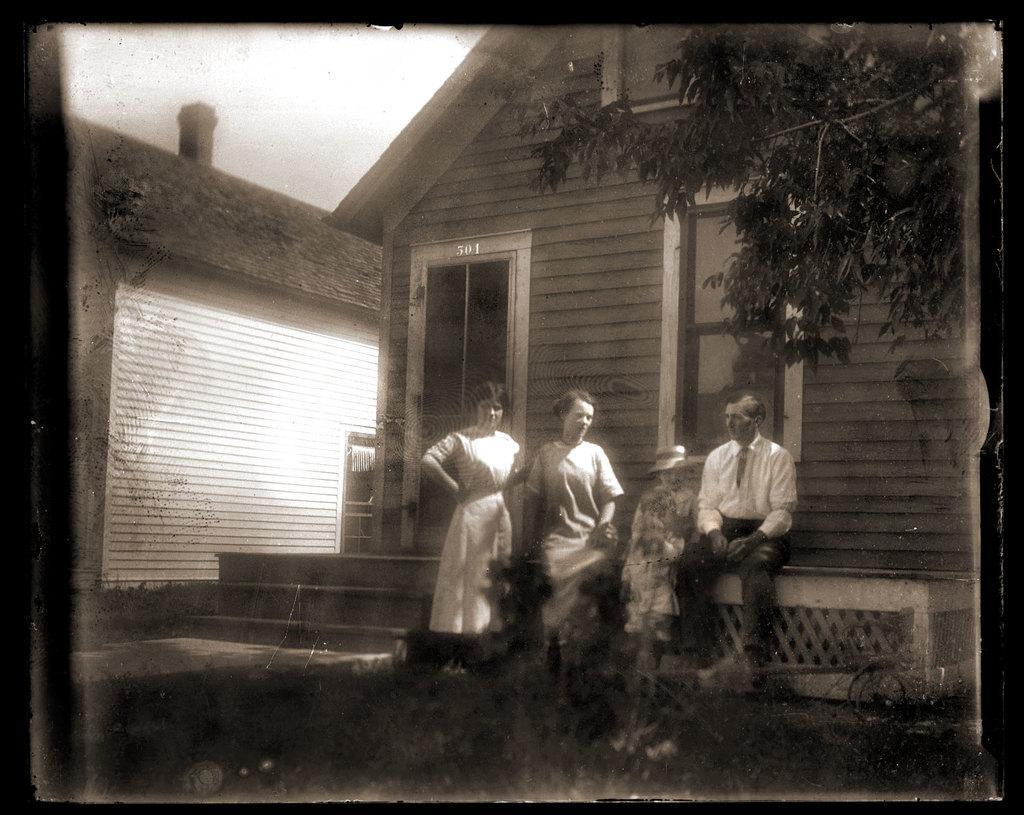Can you describe this image briefly? In this image I can see three people wearing the dresses. To the back of the people I can see the house with the windows. To the right I can see the tree and this is a black and white image. 